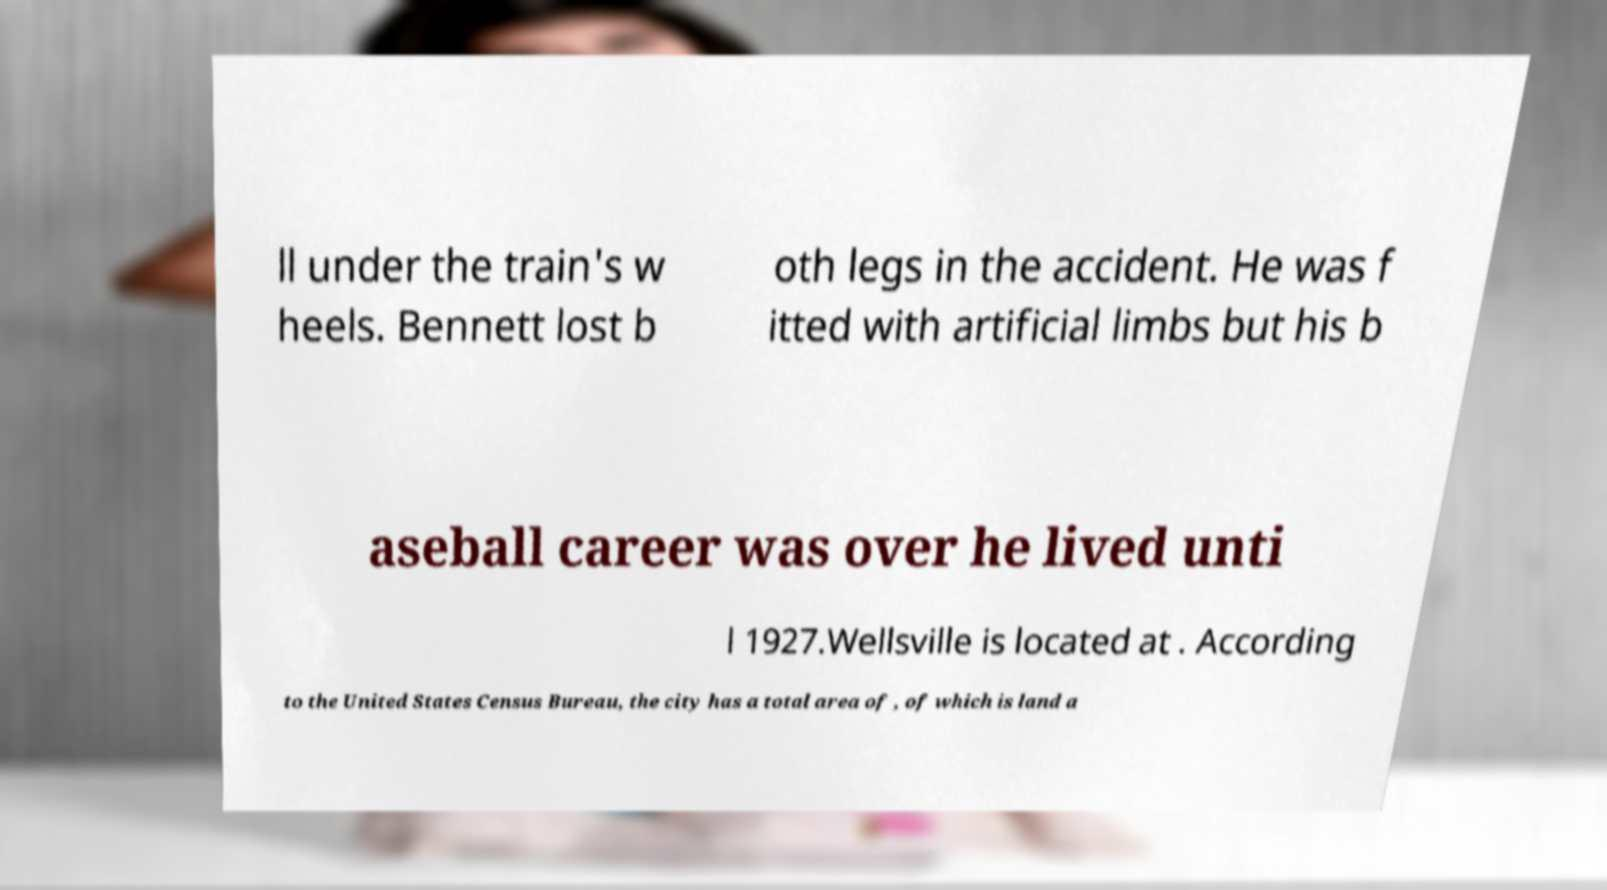Please identify and transcribe the text found in this image. ll under the train's w heels. Bennett lost b oth legs in the accident. He was f itted with artificial limbs but his b aseball career was over he lived unti l 1927.Wellsville is located at . According to the United States Census Bureau, the city has a total area of , of which is land a 